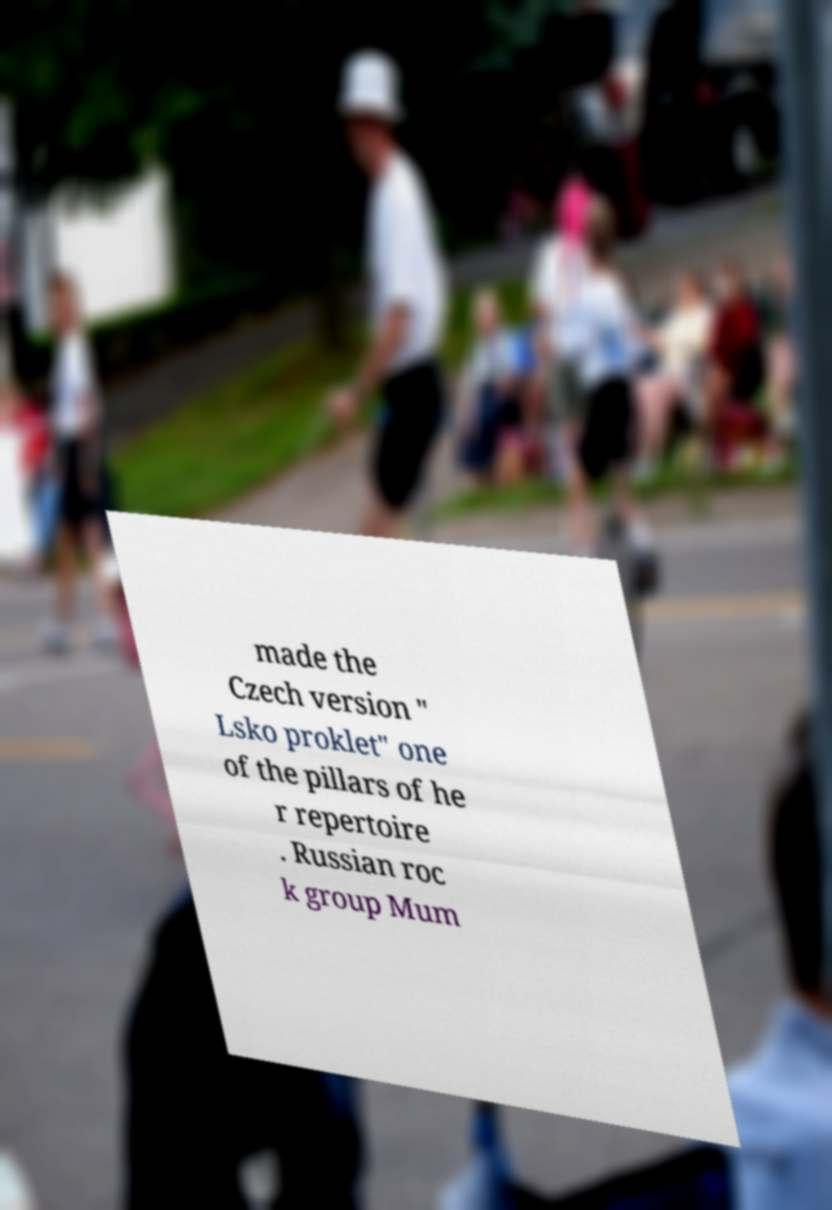Could you assist in decoding the text presented in this image and type it out clearly? made the Czech version " Lsko proklet" one of the pillars of he r repertoire . Russian roc k group Mum 